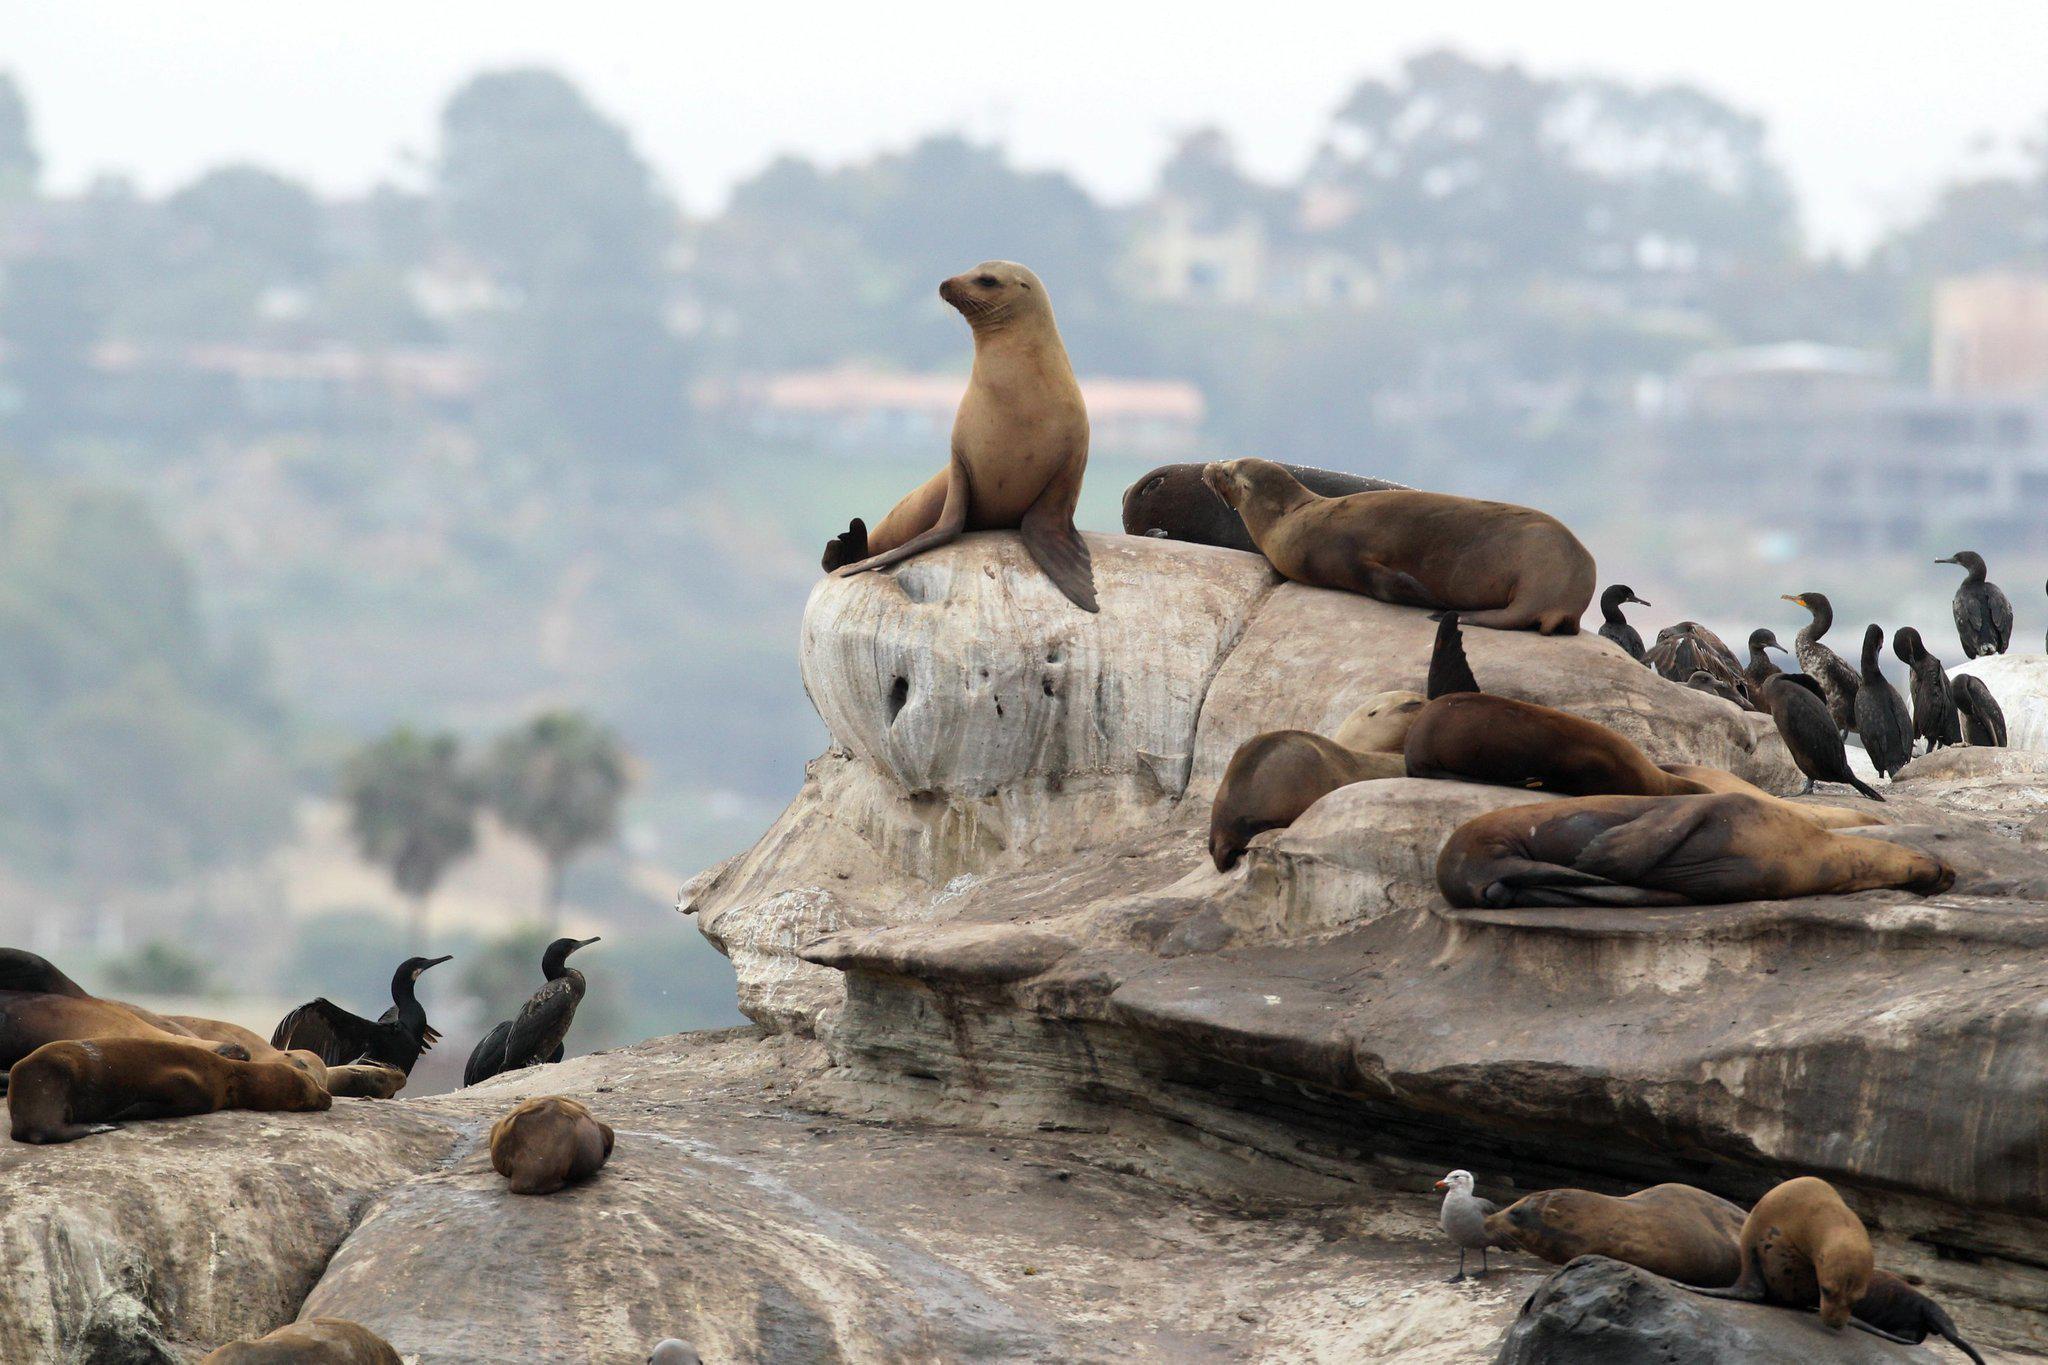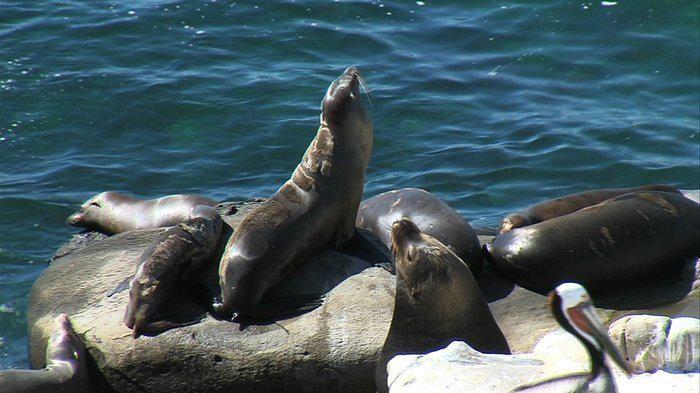The first image is the image on the left, the second image is the image on the right. Examine the images to the left and right. Is the description "A seal is sitting on a large, elevated rock." accurate? Answer yes or no. Yes. The first image is the image on the left, the second image is the image on the right. Evaluate the accuracy of this statement regarding the images: "An image shows multiple seals lying on a plank-look manmade structure.". Is it true? Answer yes or no. No. 